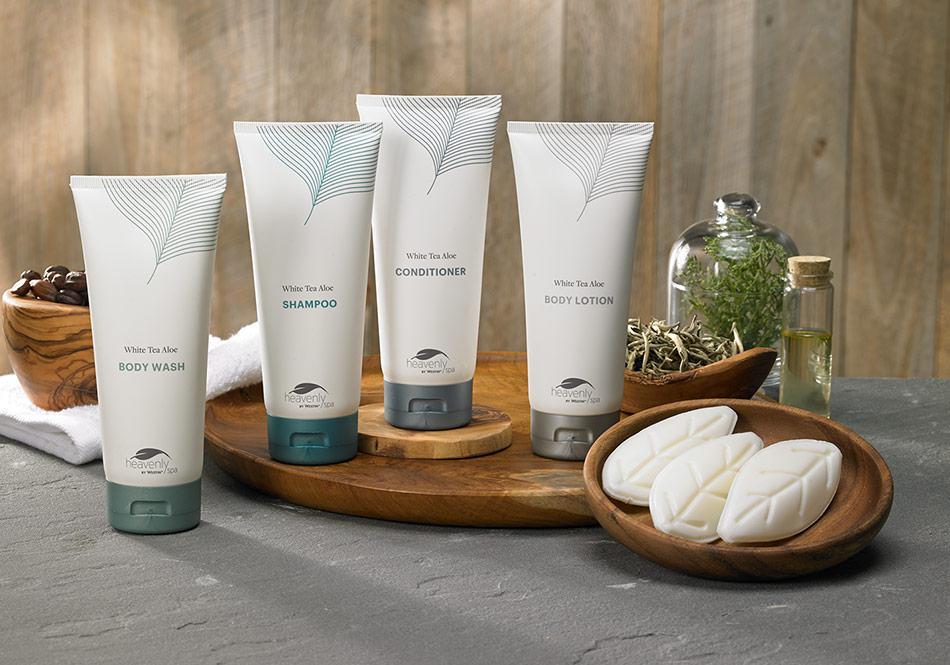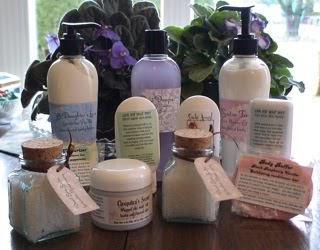The first image is the image on the left, the second image is the image on the right. Considering the images on both sides, is "One image shows a variety of skincare products displayed upright on a table, and the other image shows a variety of skincare products, all of them in a container with sides." valid? Answer yes or no. No. 